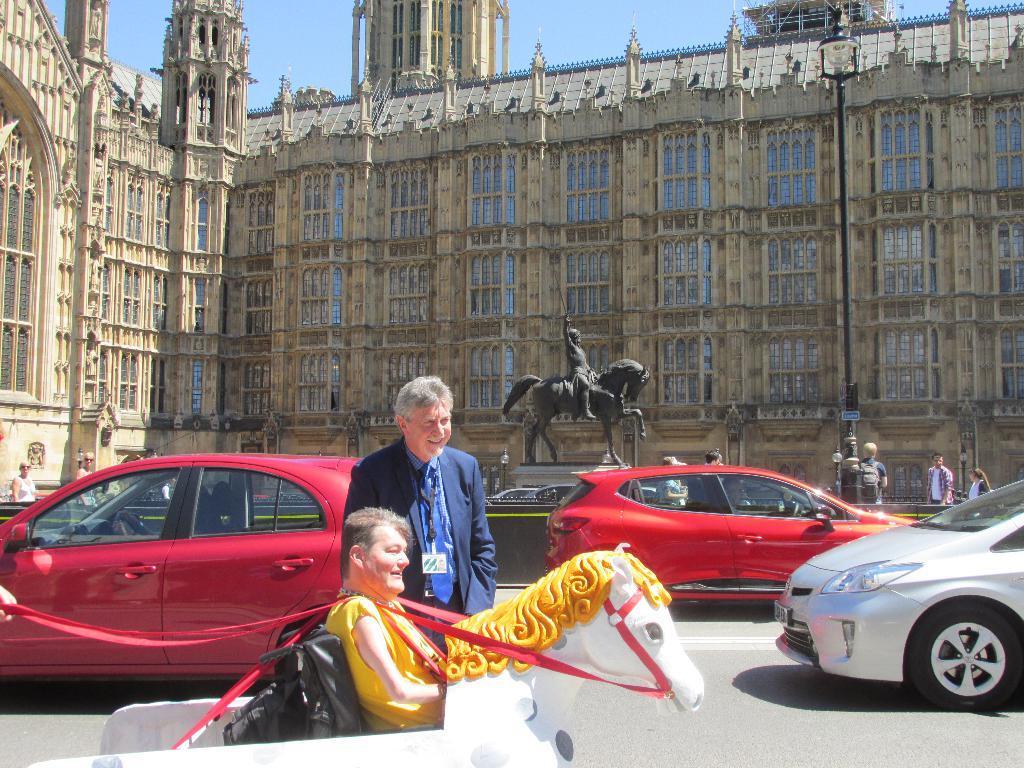Please provide a concise description of this image. The image is taken on the road. In the center of the image there is a man standing. There are cars. In the background there is a statue, building, and a sky. 